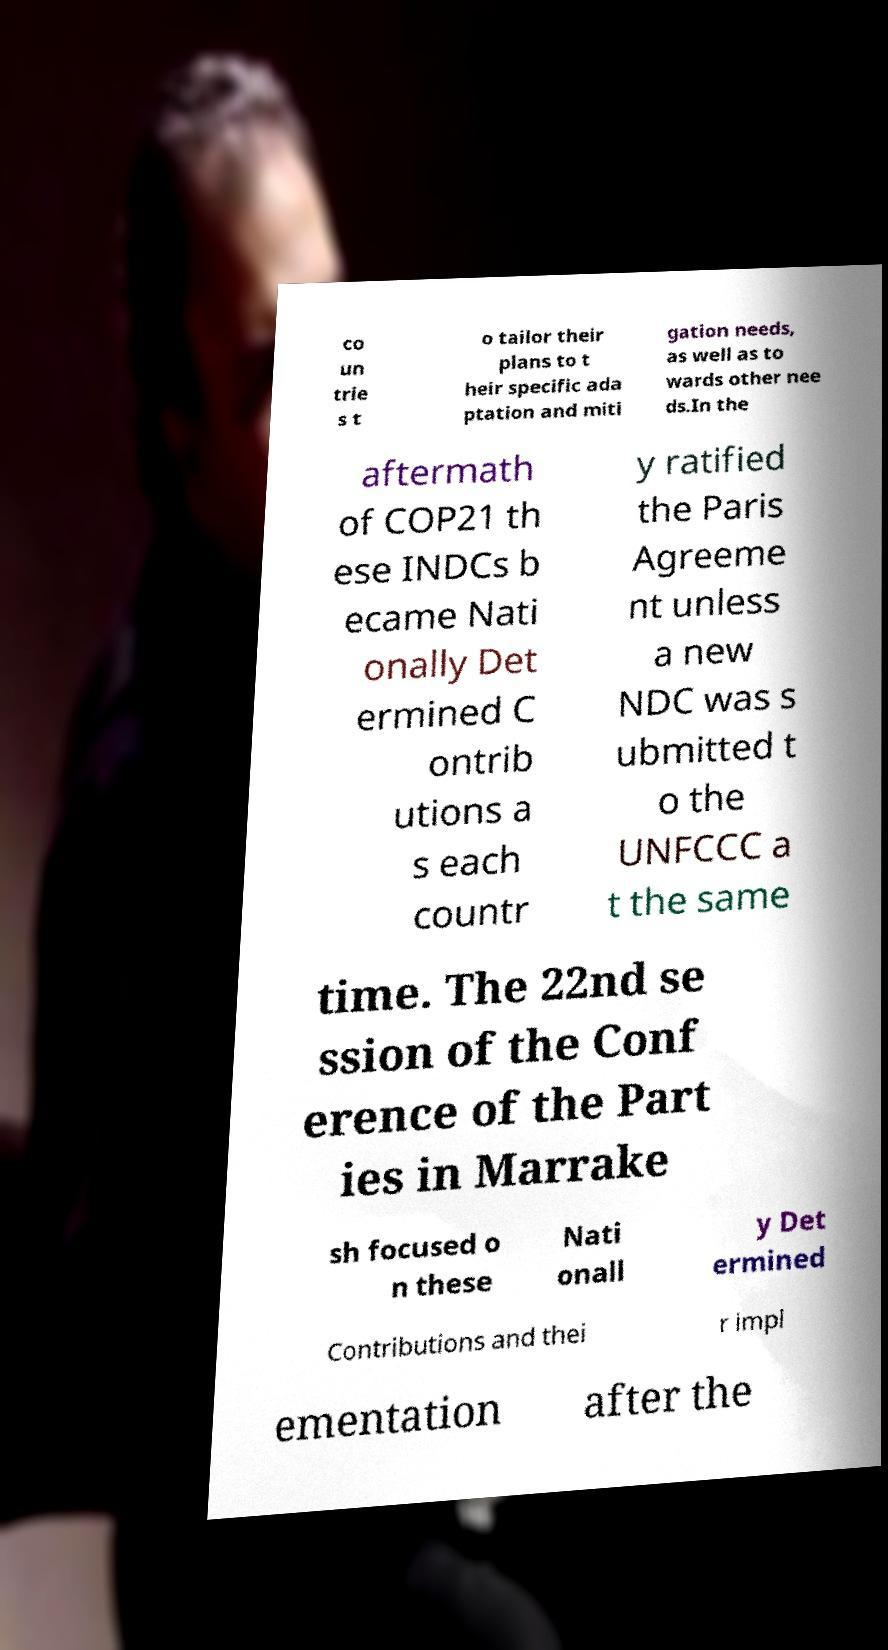Could you assist in decoding the text presented in this image and type it out clearly? co un trie s t o tailor their plans to t heir specific ada ptation and miti gation needs, as well as to wards other nee ds.In the aftermath of COP21 th ese INDCs b ecame Nati onally Det ermined C ontrib utions a s each countr y ratified the Paris Agreeme nt unless a new NDC was s ubmitted t o the UNFCCC a t the same time. The 22nd se ssion of the Conf erence of the Part ies in Marrake sh focused o n these Nati onall y Det ermined Contributions and thei r impl ementation after the 